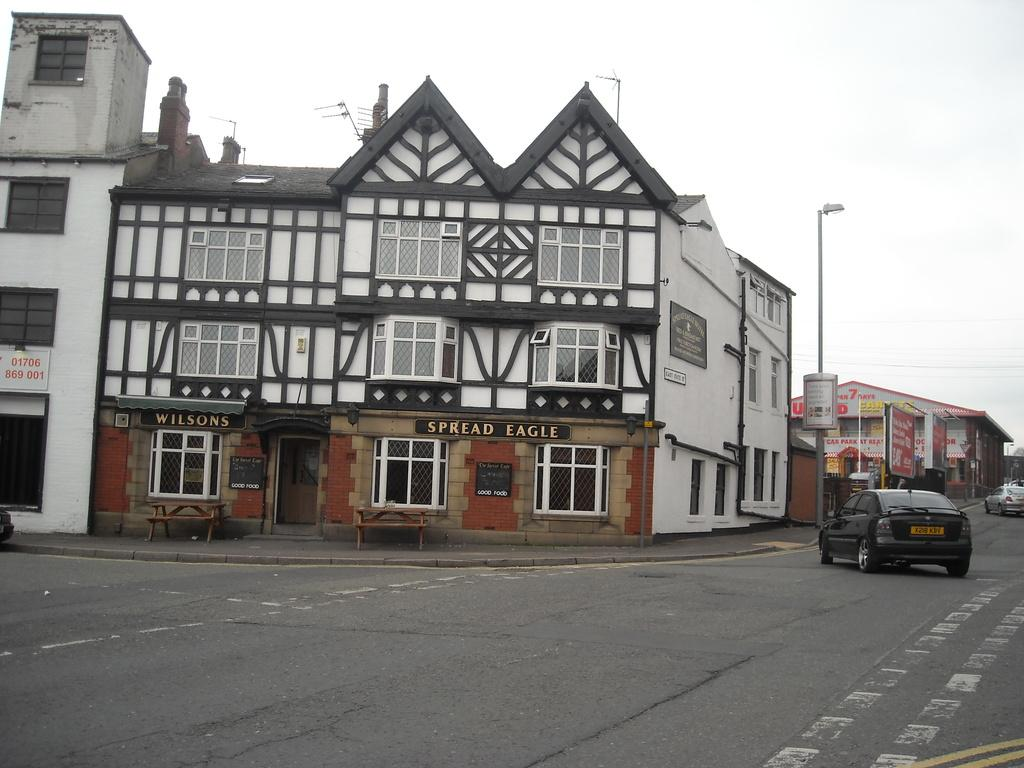What can be seen on the road in the image? There are vehicles on the road in the image. What type of structures are present in the image? There are buildings in the image. What part of the buildings can be seen in the image? Windows are visible in the image. What other objects can be seen in the image? There are boards and poles in the image. What is visible in the background of the image? The sky is visible in the background of the image. How much money is being exchanged between the vehicles in the image? There is no indication of money being exchanged between the vehicles in the image. What type of pollution can be seen in the image? There is no visible pollution in the image. 